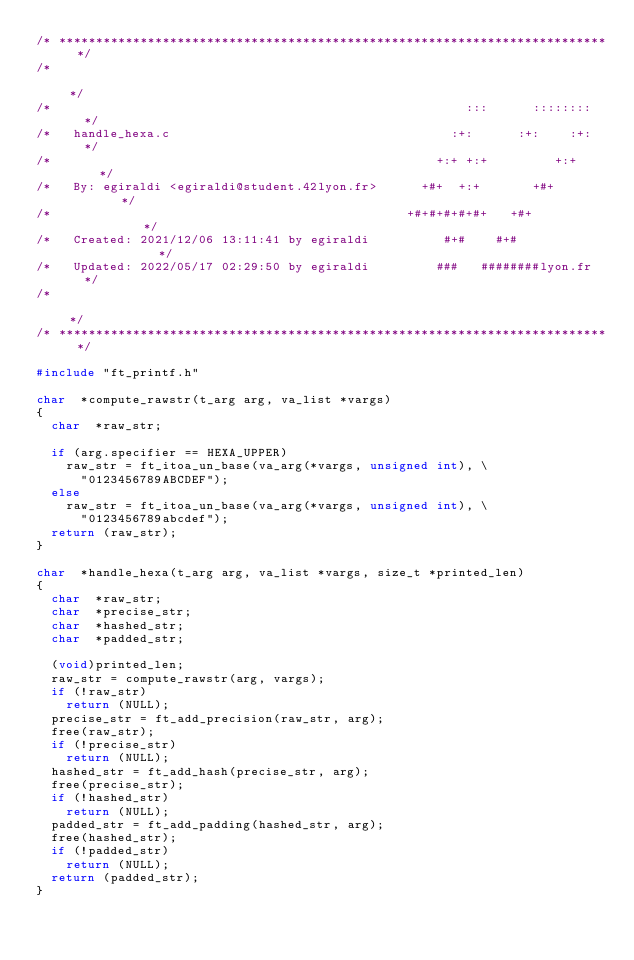<code> <loc_0><loc_0><loc_500><loc_500><_C_>/* ************************************************************************** */
/*                                                                            */
/*                                                        :::      ::::::::   */
/*   handle_hexa.c                                      :+:      :+:    :+:   */
/*                                                    +:+ +:+         +:+     */
/*   By: egiraldi <egiraldi@student.42lyon.fr>      +#+  +:+       +#+        */
/*                                                +#+#+#+#+#+   +#+           */
/*   Created: 2021/12/06 13:11:41 by egiraldi          #+#    #+#             */
/*   Updated: 2022/05/17 02:29:50 by egiraldi         ###   ########lyon.fr   */
/*                                                                            */
/* ************************************************************************** */

#include "ft_printf.h"

char	*compute_rawstr(t_arg arg, va_list *vargs)
{
	char	*raw_str;

	if (arg.specifier == HEXA_UPPER)
		raw_str = ft_itoa_un_base(va_arg(*vargs, unsigned int), \
			"0123456789ABCDEF");
	else
		raw_str = ft_itoa_un_base(va_arg(*vargs, unsigned int), \
			"0123456789abcdef");
	return (raw_str);
}

char	*handle_hexa(t_arg arg, va_list *vargs, size_t *printed_len)
{
	char	*raw_str;
	char	*precise_str;
	char	*hashed_str;
	char	*padded_str;

	(void)printed_len;
	raw_str = compute_rawstr(arg, vargs);
	if (!raw_str)
		return (NULL);
	precise_str = ft_add_precision(raw_str, arg);
	free(raw_str);
	if (!precise_str)
		return (NULL);
	hashed_str = ft_add_hash(precise_str, arg);
	free(precise_str);
	if (!hashed_str)
		return (NULL);
	padded_str = ft_add_padding(hashed_str, arg);
	free(hashed_str);
	if (!padded_str)
		return (NULL);
	return (padded_str);
}
</code> 